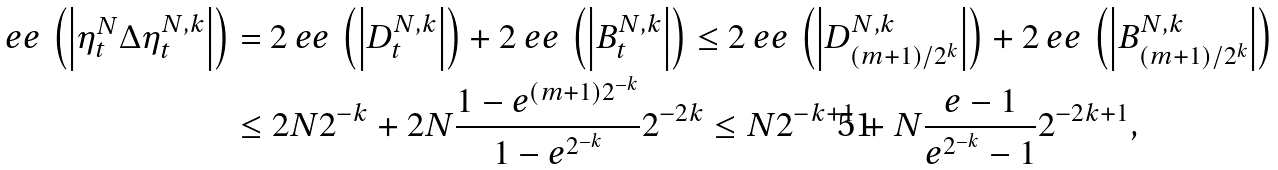Convert formula to latex. <formula><loc_0><loc_0><loc_500><loc_500>\ e e \, \left ( \left | \eta ^ { N } _ { t } \Delta \eta ^ { N , k } _ { t } \right | \right ) & = 2 \ e e \, \left ( \left | D ^ { N , k } _ { t } \right | \right ) + 2 \ e e \, \left ( \left | B ^ { N , k } _ { t } \right | \right ) \leq 2 \ e e \, \left ( \left | D ^ { N , k } _ { ( m + 1 ) / 2 ^ { k } } \right | \right ) + 2 \ e e \, \left ( \left | B ^ { N , k } _ { ( m + 1 ) / 2 ^ { k } } \right | \right ) \\ & \leq 2 N 2 ^ { - k } + 2 N \frac { 1 - e ^ { ( m + 1 ) 2 ^ { - k } } } { 1 - e ^ { 2 ^ { - k } } } 2 ^ { - 2 k } \leq N 2 ^ { - k + 1 } + N \frac { e - 1 } { e ^ { 2 ^ { - k } } - 1 } 2 ^ { - 2 k + 1 } ,</formula> 